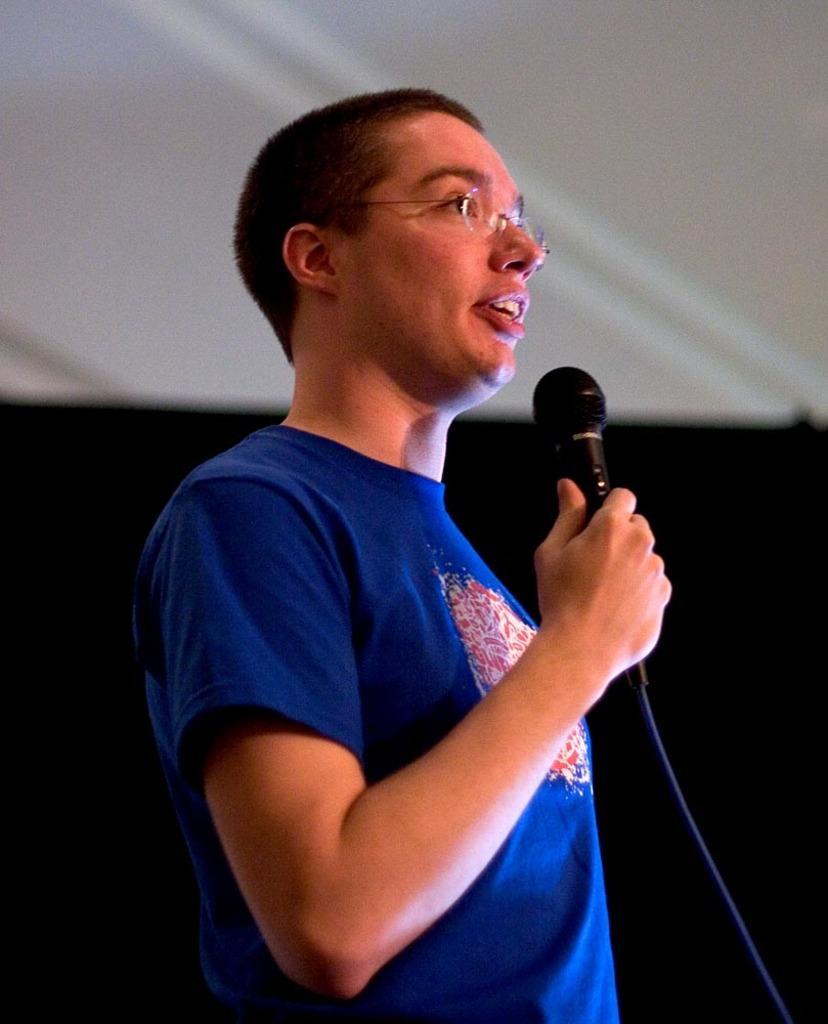Describe this image in one or two sentences. In this image I can see a person wearing blue colored t shirt is holding a microphone in his hand. I can see the white and black colored background. 